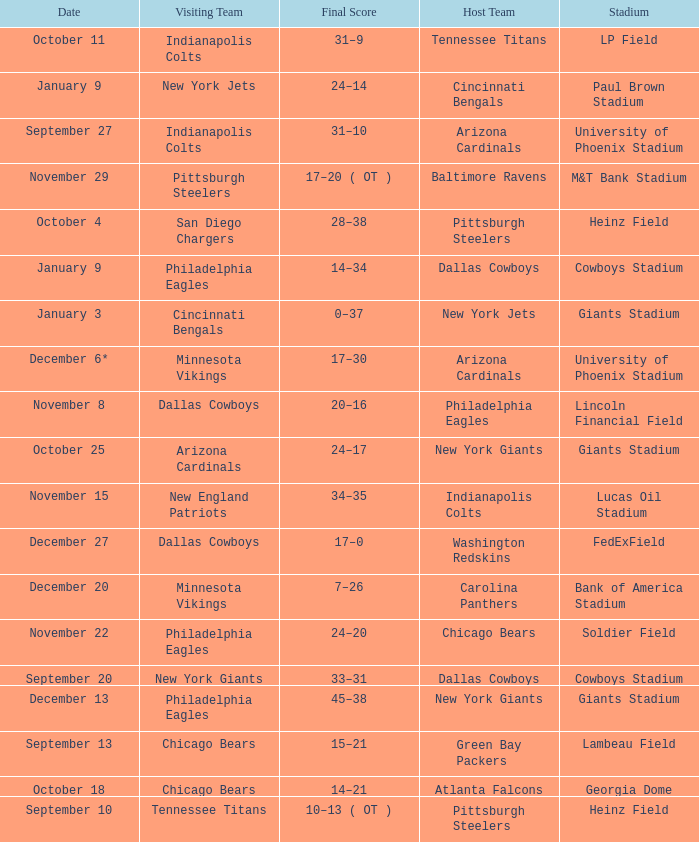Tell me the visiting team for october 4 San Diego Chargers. 